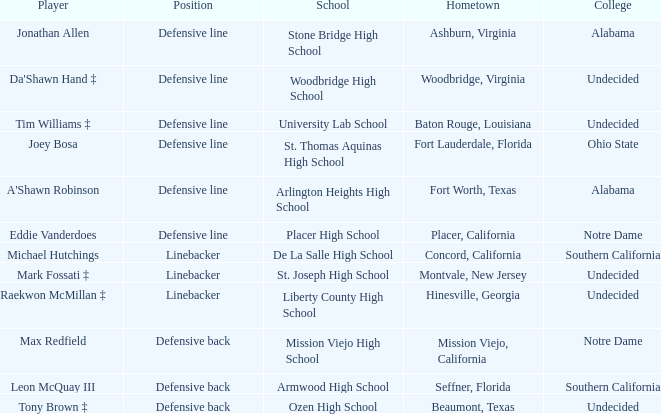What is the location of the player from fort lauderdale, florida? Defensive line. 